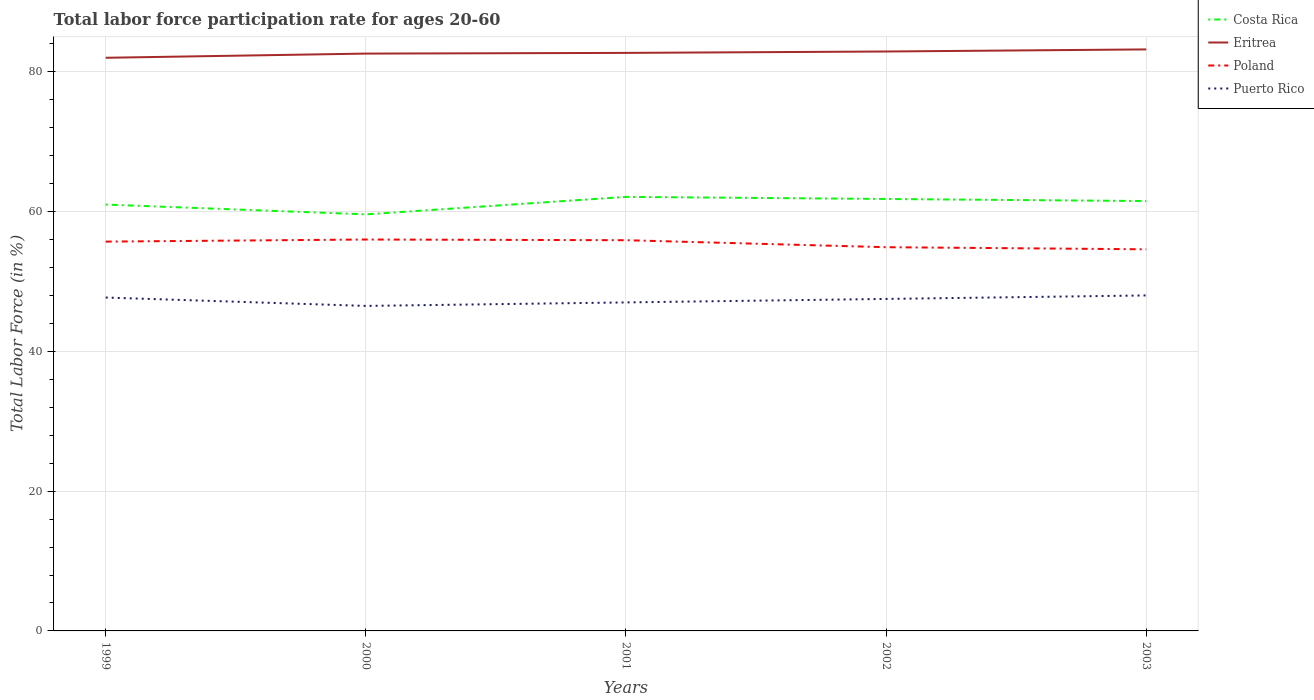Across all years, what is the maximum labor force participation rate in Costa Rica?
Offer a terse response. 59.6. In which year was the labor force participation rate in Eritrea maximum?
Your answer should be compact. 1999. What is the total labor force participation rate in Costa Rica in the graph?
Your response must be concise. 0.3. What is the difference between the highest and the second highest labor force participation rate in Poland?
Offer a very short reply. 1.4. What is the difference between the highest and the lowest labor force participation rate in Poland?
Offer a terse response. 3. Is the labor force participation rate in Puerto Rico strictly greater than the labor force participation rate in Eritrea over the years?
Ensure brevity in your answer.  Yes. Does the graph contain any zero values?
Ensure brevity in your answer.  No. What is the title of the graph?
Provide a short and direct response. Total labor force participation rate for ages 20-60. What is the Total Labor Force (in %) of Eritrea in 1999?
Ensure brevity in your answer.  82. What is the Total Labor Force (in %) of Poland in 1999?
Make the answer very short. 55.7. What is the Total Labor Force (in %) in Puerto Rico in 1999?
Your response must be concise. 47.7. What is the Total Labor Force (in %) of Costa Rica in 2000?
Give a very brief answer. 59.6. What is the Total Labor Force (in %) in Eritrea in 2000?
Make the answer very short. 82.6. What is the Total Labor Force (in %) of Poland in 2000?
Provide a short and direct response. 56. What is the Total Labor Force (in %) of Puerto Rico in 2000?
Offer a very short reply. 46.5. What is the Total Labor Force (in %) in Costa Rica in 2001?
Provide a succinct answer. 62.1. What is the Total Labor Force (in %) of Eritrea in 2001?
Your answer should be very brief. 82.7. What is the Total Labor Force (in %) of Poland in 2001?
Make the answer very short. 55.9. What is the Total Labor Force (in %) in Costa Rica in 2002?
Offer a very short reply. 61.8. What is the Total Labor Force (in %) in Eritrea in 2002?
Your response must be concise. 82.9. What is the Total Labor Force (in %) of Poland in 2002?
Offer a terse response. 54.9. What is the Total Labor Force (in %) of Puerto Rico in 2002?
Ensure brevity in your answer.  47.5. What is the Total Labor Force (in %) in Costa Rica in 2003?
Offer a very short reply. 61.5. What is the Total Labor Force (in %) in Eritrea in 2003?
Give a very brief answer. 83.2. What is the Total Labor Force (in %) in Poland in 2003?
Ensure brevity in your answer.  54.6. What is the Total Labor Force (in %) of Puerto Rico in 2003?
Provide a short and direct response. 48. Across all years, what is the maximum Total Labor Force (in %) in Costa Rica?
Keep it short and to the point. 62.1. Across all years, what is the maximum Total Labor Force (in %) in Eritrea?
Your answer should be very brief. 83.2. Across all years, what is the minimum Total Labor Force (in %) of Costa Rica?
Ensure brevity in your answer.  59.6. Across all years, what is the minimum Total Labor Force (in %) of Eritrea?
Your answer should be very brief. 82. Across all years, what is the minimum Total Labor Force (in %) in Poland?
Offer a terse response. 54.6. Across all years, what is the minimum Total Labor Force (in %) of Puerto Rico?
Offer a very short reply. 46.5. What is the total Total Labor Force (in %) of Costa Rica in the graph?
Offer a very short reply. 306. What is the total Total Labor Force (in %) in Eritrea in the graph?
Your answer should be compact. 413.4. What is the total Total Labor Force (in %) in Poland in the graph?
Give a very brief answer. 277.1. What is the total Total Labor Force (in %) of Puerto Rico in the graph?
Offer a very short reply. 236.7. What is the difference between the Total Labor Force (in %) in Costa Rica in 1999 and that in 2000?
Your answer should be compact. 1.4. What is the difference between the Total Labor Force (in %) of Eritrea in 1999 and that in 2000?
Provide a short and direct response. -0.6. What is the difference between the Total Labor Force (in %) of Poland in 1999 and that in 2000?
Offer a very short reply. -0.3. What is the difference between the Total Labor Force (in %) of Puerto Rico in 1999 and that in 2000?
Provide a short and direct response. 1.2. What is the difference between the Total Labor Force (in %) of Eritrea in 1999 and that in 2001?
Keep it short and to the point. -0.7. What is the difference between the Total Labor Force (in %) of Puerto Rico in 1999 and that in 2001?
Ensure brevity in your answer.  0.7. What is the difference between the Total Labor Force (in %) in Costa Rica in 1999 and that in 2002?
Keep it short and to the point. -0.8. What is the difference between the Total Labor Force (in %) in Poland in 1999 and that in 2003?
Offer a terse response. 1.1. What is the difference between the Total Labor Force (in %) in Puerto Rico in 1999 and that in 2003?
Give a very brief answer. -0.3. What is the difference between the Total Labor Force (in %) of Costa Rica in 2000 and that in 2001?
Your response must be concise. -2.5. What is the difference between the Total Labor Force (in %) in Eritrea in 2000 and that in 2001?
Your answer should be compact. -0.1. What is the difference between the Total Labor Force (in %) in Eritrea in 2000 and that in 2002?
Give a very brief answer. -0.3. What is the difference between the Total Labor Force (in %) in Poland in 2000 and that in 2002?
Your answer should be very brief. 1.1. What is the difference between the Total Labor Force (in %) of Puerto Rico in 2000 and that in 2002?
Ensure brevity in your answer.  -1. What is the difference between the Total Labor Force (in %) of Costa Rica in 2000 and that in 2003?
Your answer should be compact. -1.9. What is the difference between the Total Labor Force (in %) in Eritrea in 2000 and that in 2003?
Offer a very short reply. -0.6. What is the difference between the Total Labor Force (in %) in Poland in 2000 and that in 2003?
Provide a short and direct response. 1.4. What is the difference between the Total Labor Force (in %) of Puerto Rico in 2000 and that in 2003?
Provide a short and direct response. -1.5. What is the difference between the Total Labor Force (in %) in Costa Rica in 2001 and that in 2002?
Your answer should be very brief. 0.3. What is the difference between the Total Labor Force (in %) of Eritrea in 2001 and that in 2003?
Give a very brief answer. -0.5. What is the difference between the Total Labor Force (in %) in Poland in 2001 and that in 2003?
Offer a terse response. 1.3. What is the difference between the Total Labor Force (in %) of Puerto Rico in 2001 and that in 2003?
Keep it short and to the point. -1. What is the difference between the Total Labor Force (in %) in Costa Rica in 2002 and that in 2003?
Give a very brief answer. 0.3. What is the difference between the Total Labor Force (in %) of Costa Rica in 1999 and the Total Labor Force (in %) of Eritrea in 2000?
Give a very brief answer. -21.6. What is the difference between the Total Labor Force (in %) in Costa Rica in 1999 and the Total Labor Force (in %) in Puerto Rico in 2000?
Your response must be concise. 14.5. What is the difference between the Total Labor Force (in %) of Eritrea in 1999 and the Total Labor Force (in %) of Puerto Rico in 2000?
Your answer should be compact. 35.5. What is the difference between the Total Labor Force (in %) of Poland in 1999 and the Total Labor Force (in %) of Puerto Rico in 2000?
Make the answer very short. 9.2. What is the difference between the Total Labor Force (in %) of Costa Rica in 1999 and the Total Labor Force (in %) of Eritrea in 2001?
Keep it short and to the point. -21.7. What is the difference between the Total Labor Force (in %) in Costa Rica in 1999 and the Total Labor Force (in %) in Poland in 2001?
Your response must be concise. 5.1. What is the difference between the Total Labor Force (in %) in Costa Rica in 1999 and the Total Labor Force (in %) in Puerto Rico in 2001?
Keep it short and to the point. 14. What is the difference between the Total Labor Force (in %) of Eritrea in 1999 and the Total Labor Force (in %) of Poland in 2001?
Provide a short and direct response. 26.1. What is the difference between the Total Labor Force (in %) of Costa Rica in 1999 and the Total Labor Force (in %) of Eritrea in 2002?
Give a very brief answer. -21.9. What is the difference between the Total Labor Force (in %) in Costa Rica in 1999 and the Total Labor Force (in %) in Puerto Rico in 2002?
Offer a terse response. 13.5. What is the difference between the Total Labor Force (in %) in Eritrea in 1999 and the Total Labor Force (in %) in Poland in 2002?
Offer a very short reply. 27.1. What is the difference between the Total Labor Force (in %) of Eritrea in 1999 and the Total Labor Force (in %) of Puerto Rico in 2002?
Offer a terse response. 34.5. What is the difference between the Total Labor Force (in %) in Poland in 1999 and the Total Labor Force (in %) in Puerto Rico in 2002?
Give a very brief answer. 8.2. What is the difference between the Total Labor Force (in %) of Costa Rica in 1999 and the Total Labor Force (in %) of Eritrea in 2003?
Make the answer very short. -22.2. What is the difference between the Total Labor Force (in %) of Costa Rica in 1999 and the Total Labor Force (in %) of Puerto Rico in 2003?
Your response must be concise. 13. What is the difference between the Total Labor Force (in %) of Eritrea in 1999 and the Total Labor Force (in %) of Poland in 2003?
Your response must be concise. 27.4. What is the difference between the Total Labor Force (in %) of Eritrea in 1999 and the Total Labor Force (in %) of Puerto Rico in 2003?
Your response must be concise. 34. What is the difference between the Total Labor Force (in %) in Poland in 1999 and the Total Labor Force (in %) in Puerto Rico in 2003?
Provide a short and direct response. 7.7. What is the difference between the Total Labor Force (in %) in Costa Rica in 2000 and the Total Labor Force (in %) in Eritrea in 2001?
Provide a succinct answer. -23.1. What is the difference between the Total Labor Force (in %) of Costa Rica in 2000 and the Total Labor Force (in %) of Poland in 2001?
Offer a very short reply. 3.7. What is the difference between the Total Labor Force (in %) in Eritrea in 2000 and the Total Labor Force (in %) in Poland in 2001?
Provide a short and direct response. 26.7. What is the difference between the Total Labor Force (in %) in Eritrea in 2000 and the Total Labor Force (in %) in Puerto Rico in 2001?
Give a very brief answer. 35.6. What is the difference between the Total Labor Force (in %) in Poland in 2000 and the Total Labor Force (in %) in Puerto Rico in 2001?
Offer a very short reply. 9. What is the difference between the Total Labor Force (in %) of Costa Rica in 2000 and the Total Labor Force (in %) of Eritrea in 2002?
Provide a succinct answer. -23.3. What is the difference between the Total Labor Force (in %) in Eritrea in 2000 and the Total Labor Force (in %) in Poland in 2002?
Keep it short and to the point. 27.7. What is the difference between the Total Labor Force (in %) of Eritrea in 2000 and the Total Labor Force (in %) of Puerto Rico in 2002?
Your answer should be compact. 35.1. What is the difference between the Total Labor Force (in %) in Poland in 2000 and the Total Labor Force (in %) in Puerto Rico in 2002?
Provide a succinct answer. 8.5. What is the difference between the Total Labor Force (in %) in Costa Rica in 2000 and the Total Labor Force (in %) in Eritrea in 2003?
Your answer should be very brief. -23.6. What is the difference between the Total Labor Force (in %) of Costa Rica in 2000 and the Total Labor Force (in %) of Puerto Rico in 2003?
Offer a very short reply. 11.6. What is the difference between the Total Labor Force (in %) of Eritrea in 2000 and the Total Labor Force (in %) of Puerto Rico in 2003?
Offer a terse response. 34.6. What is the difference between the Total Labor Force (in %) of Costa Rica in 2001 and the Total Labor Force (in %) of Eritrea in 2002?
Ensure brevity in your answer.  -20.8. What is the difference between the Total Labor Force (in %) in Costa Rica in 2001 and the Total Labor Force (in %) in Poland in 2002?
Make the answer very short. 7.2. What is the difference between the Total Labor Force (in %) of Eritrea in 2001 and the Total Labor Force (in %) of Poland in 2002?
Ensure brevity in your answer.  27.8. What is the difference between the Total Labor Force (in %) in Eritrea in 2001 and the Total Labor Force (in %) in Puerto Rico in 2002?
Provide a succinct answer. 35.2. What is the difference between the Total Labor Force (in %) in Poland in 2001 and the Total Labor Force (in %) in Puerto Rico in 2002?
Your answer should be compact. 8.4. What is the difference between the Total Labor Force (in %) of Costa Rica in 2001 and the Total Labor Force (in %) of Eritrea in 2003?
Provide a short and direct response. -21.1. What is the difference between the Total Labor Force (in %) of Costa Rica in 2001 and the Total Labor Force (in %) of Poland in 2003?
Make the answer very short. 7.5. What is the difference between the Total Labor Force (in %) in Costa Rica in 2001 and the Total Labor Force (in %) in Puerto Rico in 2003?
Your answer should be very brief. 14.1. What is the difference between the Total Labor Force (in %) in Eritrea in 2001 and the Total Labor Force (in %) in Poland in 2003?
Your answer should be compact. 28.1. What is the difference between the Total Labor Force (in %) of Eritrea in 2001 and the Total Labor Force (in %) of Puerto Rico in 2003?
Offer a terse response. 34.7. What is the difference between the Total Labor Force (in %) of Poland in 2001 and the Total Labor Force (in %) of Puerto Rico in 2003?
Your response must be concise. 7.9. What is the difference between the Total Labor Force (in %) of Costa Rica in 2002 and the Total Labor Force (in %) of Eritrea in 2003?
Make the answer very short. -21.4. What is the difference between the Total Labor Force (in %) of Eritrea in 2002 and the Total Labor Force (in %) of Poland in 2003?
Your answer should be compact. 28.3. What is the difference between the Total Labor Force (in %) of Eritrea in 2002 and the Total Labor Force (in %) of Puerto Rico in 2003?
Give a very brief answer. 34.9. What is the difference between the Total Labor Force (in %) of Poland in 2002 and the Total Labor Force (in %) of Puerto Rico in 2003?
Provide a succinct answer. 6.9. What is the average Total Labor Force (in %) of Costa Rica per year?
Offer a very short reply. 61.2. What is the average Total Labor Force (in %) in Eritrea per year?
Provide a succinct answer. 82.68. What is the average Total Labor Force (in %) in Poland per year?
Provide a short and direct response. 55.42. What is the average Total Labor Force (in %) of Puerto Rico per year?
Ensure brevity in your answer.  47.34. In the year 1999, what is the difference between the Total Labor Force (in %) in Costa Rica and Total Labor Force (in %) in Eritrea?
Keep it short and to the point. -21. In the year 1999, what is the difference between the Total Labor Force (in %) in Costa Rica and Total Labor Force (in %) in Puerto Rico?
Give a very brief answer. 13.3. In the year 1999, what is the difference between the Total Labor Force (in %) of Eritrea and Total Labor Force (in %) of Poland?
Give a very brief answer. 26.3. In the year 1999, what is the difference between the Total Labor Force (in %) of Eritrea and Total Labor Force (in %) of Puerto Rico?
Provide a succinct answer. 34.3. In the year 1999, what is the difference between the Total Labor Force (in %) of Poland and Total Labor Force (in %) of Puerto Rico?
Your answer should be compact. 8. In the year 2000, what is the difference between the Total Labor Force (in %) of Costa Rica and Total Labor Force (in %) of Puerto Rico?
Make the answer very short. 13.1. In the year 2000, what is the difference between the Total Labor Force (in %) in Eritrea and Total Labor Force (in %) in Poland?
Ensure brevity in your answer.  26.6. In the year 2000, what is the difference between the Total Labor Force (in %) in Eritrea and Total Labor Force (in %) in Puerto Rico?
Offer a very short reply. 36.1. In the year 2000, what is the difference between the Total Labor Force (in %) of Poland and Total Labor Force (in %) of Puerto Rico?
Ensure brevity in your answer.  9.5. In the year 2001, what is the difference between the Total Labor Force (in %) in Costa Rica and Total Labor Force (in %) in Eritrea?
Make the answer very short. -20.6. In the year 2001, what is the difference between the Total Labor Force (in %) in Costa Rica and Total Labor Force (in %) in Poland?
Keep it short and to the point. 6.2. In the year 2001, what is the difference between the Total Labor Force (in %) of Costa Rica and Total Labor Force (in %) of Puerto Rico?
Offer a terse response. 15.1. In the year 2001, what is the difference between the Total Labor Force (in %) in Eritrea and Total Labor Force (in %) in Poland?
Offer a terse response. 26.8. In the year 2001, what is the difference between the Total Labor Force (in %) of Eritrea and Total Labor Force (in %) of Puerto Rico?
Provide a succinct answer. 35.7. In the year 2002, what is the difference between the Total Labor Force (in %) in Costa Rica and Total Labor Force (in %) in Eritrea?
Provide a succinct answer. -21.1. In the year 2002, what is the difference between the Total Labor Force (in %) of Costa Rica and Total Labor Force (in %) of Poland?
Offer a very short reply. 6.9. In the year 2002, what is the difference between the Total Labor Force (in %) in Costa Rica and Total Labor Force (in %) in Puerto Rico?
Your response must be concise. 14.3. In the year 2002, what is the difference between the Total Labor Force (in %) in Eritrea and Total Labor Force (in %) in Puerto Rico?
Your answer should be very brief. 35.4. In the year 2003, what is the difference between the Total Labor Force (in %) of Costa Rica and Total Labor Force (in %) of Eritrea?
Provide a short and direct response. -21.7. In the year 2003, what is the difference between the Total Labor Force (in %) of Costa Rica and Total Labor Force (in %) of Poland?
Make the answer very short. 6.9. In the year 2003, what is the difference between the Total Labor Force (in %) in Costa Rica and Total Labor Force (in %) in Puerto Rico?
Offer a very short reply. 13.5. In the year 2003, what is the difference between the Total Labor Force (in %) of Eritrea and Total Labor Force (in %) of Poland?
Provide a succinct answer. 28.6. In the year 2003, what is the difference between the Total Labor Force (in %) of Eritrea and Total Labor Force (in %) of Puerto Rico?
Give a very brief answer. 35.2. In the year 2003, what is the difference between the Total Labor Force (in %) in Poland and Total Labor Force (in %) in Puerto Rico?
Make the answer very short. 6.6. What is the ratio of the Total Labor Force (in %) of Costa Rica in 1999 to that in 2000?
Provide a succinct answer. 1.02. What is the ratio of the Total Labor Force (in %) in Puerto Rico in 1999 to that in 2000?
Provide a short and direct response. 1.03. What is the ratio of the Total Labor Force (in %) in Costa Rica in 1999 to that in 2001?
Give a very brief answer. 0.98. What is the ratio of the Total Labor Force (in %) in Puerto Rico in 1999 to that in 2001?
Ensure brevity in your answer.  1.01. What is the ratio of the Total Labor Force (in %) in Costa Rica in 1999 to that in 2002?
Provide a short and direct response. 0.99. What is the ratio of the Total Labor Force (in %) in Eritrea in 1999 to that in 2002?
Provide a short and direct response. 0.99. What is the ratio of the Total Labor Force (in %) in Poland in 1999 to that in 2002?
Give a very brief answer. 1.01. What is the ratio of the Total Labor Force (in %) in Puerto Rico in 1999 to that in 2002?
Make the answer very short. 1. What is the ratio of the Total Labor Force (in %) of Eritrea in 1999 to that in 2003?
Ensure brevity in your answer.  0.99. What is the ratio of the Total Labor Force (in %) in Poland in 1999 to that in 2003?
Give a very brief answer. 1.02. What is the ratio of the Total Labor Force (in %) in Costa Rica in 2000 to that in 2001?
Provide a succinct answer. 0.96. What is the ratio of the Total Labor Force (in %) in Eritrea in 2000 to that in 2001?
Give a very brief answer. 1. What is the ratio of the Total Labor Force (in %) in Puerto Rico in 2000 to that in 2001?
Your answer should be compact. 0.99. What is the ratio of the Total Labor Force (in %) of Costa Rica in 2000 to that in 2002?
Give a very brief answer. 0.96. What is the ratio of the Total Labor Force (in %) of Eritrea in 2000 to that in 2002?
Your answer should be compact. 1. What is the ratio of the Total Labor Force (in %) in Puerto Rico in 2000 to that in 2002?
Your answer should be compact. 0.98. What is the ratio of the Total Labor Force (in %) of Costa Rica in 2000 to that in 2003?
Your response must be concise. 0.97. What is the ratio of the Total Labor Force (in %) in Eritrea in 2000 to that in 2003?
Make the answer very short. 0.99. What is the ratio of the Total Labor Force (in %) of Poland in 2000 to that in 2003?
Keep it short and to the point. 1.03. What is the ratio of the Total Labor Force (in %) in Puerto Rico in 2000 to that in 2003?
Your answer should be compact. 0.97. What is the ratio of the Total Labor Force (in %) of Costa Rica in 2001 to that in 2002?
Provide a succinct answer. 1. What is the ratio of the Total Labor Force (in %) in Eritrea in 2001 to that in 2002?
Keep it short and to the point. 1. What is the ratio of the Total Labor Force (in %) of Poland in 2001 to that in 2002?
Provide a succinct answer. 1.02. What is the ratio of the Total Labor Force (in %) of Costa Rica in 2001 to that in 2003?
Your response must be concise. 1.01. What is the ratio of the Total Labor Force (in %) in Poland in 2001 to that in 2003?
Your answer should be compact. 1.02. What is the ratio of the Total Labor Force (in %) in Puerto Rico in 2001 to that in 2003?
Provide a succinct answer. 0.98. What is the ratio of the Total Labor Force (in %) in Costa Rica in 2002 to that in 2003?
Provide a succinct answer. 1. What is the difference between the highest and the second highest Total Labor Force (in %) of Costa Rica?
Ensure brevity in your answer.  0.3. What is the difference between the highest and the second highest Total Labor Force (in %) in Poland?
Give a very brief answer. 0.1. What is the difference between the highest and the second highest Total Labor Force (in %) in Puerto Rico?
Keep it short and to the point. 0.3. What is the difference between the highest and the lowest Total Labor Force (in %) of Poland?
Provide a short and direct response. 1.4. 